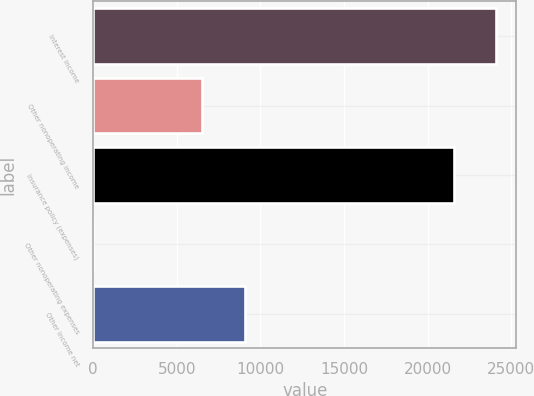Convert chart to OTSL. <chart><loc_0><loc_0><loc_500><loc_500><bar_chart><fcel>Interest income<fcel>Other nonoperating income<fcel>Insurance policy (expenses)<fcel>Other nonoperating expenses<fcel>Other income net<nl><fcel>24093<fcel>6510<fcel>21548<fcel>7<fcel>9048<nl></chart> 